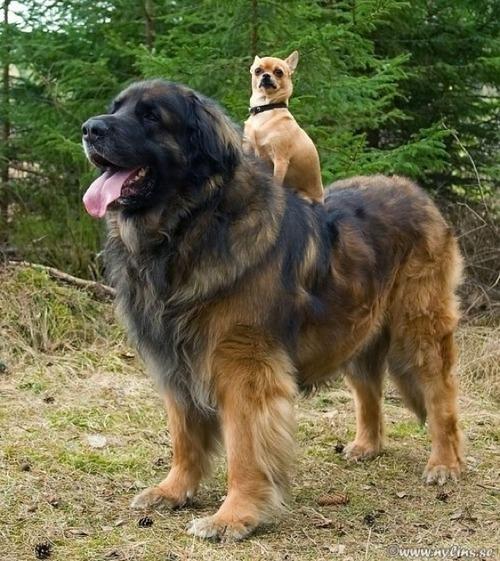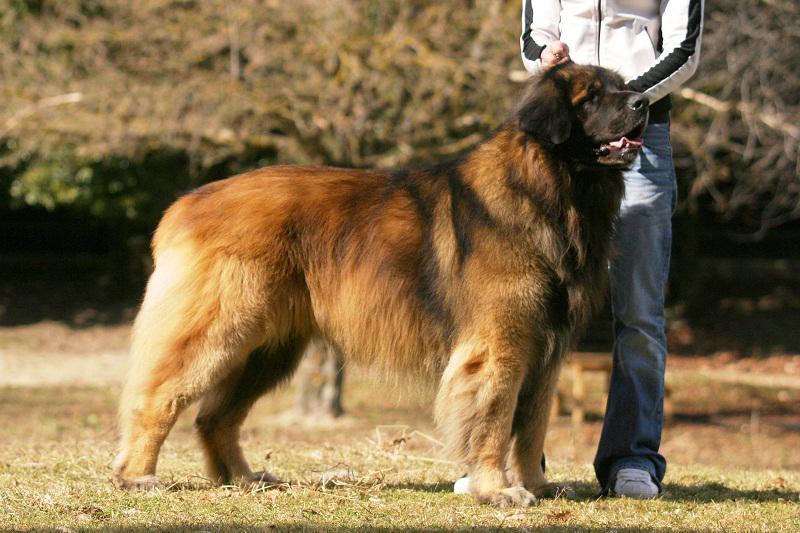The first image is the image on the left, the second image is the image on the right. Given the left and right images, does the statement "There are three dogs." hold true? Answer yes or no. Yes. 